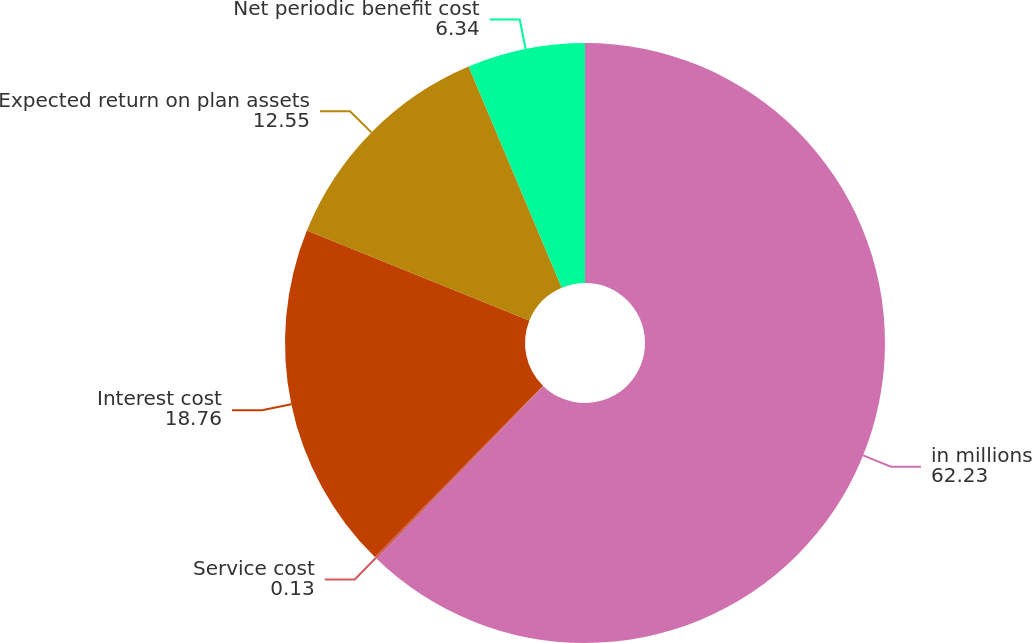Convert chart. <chart><loc_0><loc_0><loc_500><loc_500><pie_chart><fcel>in millions<fcel>Service cost<fcel>Interest cost<fcel>Expected return on plan assets<fcel>Net periodic benefit cost<nl><fcel>62.23%<fcel>0.13%<fcel>18.76%<fcel>12.55%<fcel>6.34%<nl></chart> 